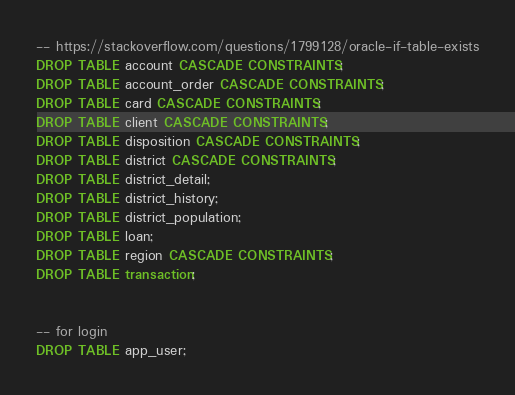Convert code to text. <code><loc_0><loc_0><loc_500><loc_500><_SQL_>-- https://stackoverflow.com/questions/1799128/oracle-if-table-exists
DROP TABLE account CASCADE CONSTRAINTS;
DROP TABLE account_order CASCADE CONSTRAINTS;
DROP TABLE card CASCADE CONSTRAINTS;
DROP TABLE client CASCADE CONSTRAINTS;
DROP TABLE disposition CASCADE CONSTRAINTS;
DROP TABLE district CASCADE CONSTRAINTS;
DROP TABLE district_detail;
DROP TABLE district_history;
DROP TABLE district_population;
DROP TABLE loan;
DROP TABLE region CASCADE CONSTRAINTS;
DROP TABLE transaction;


-- for login
DROP TABLE app_user;
</code> 